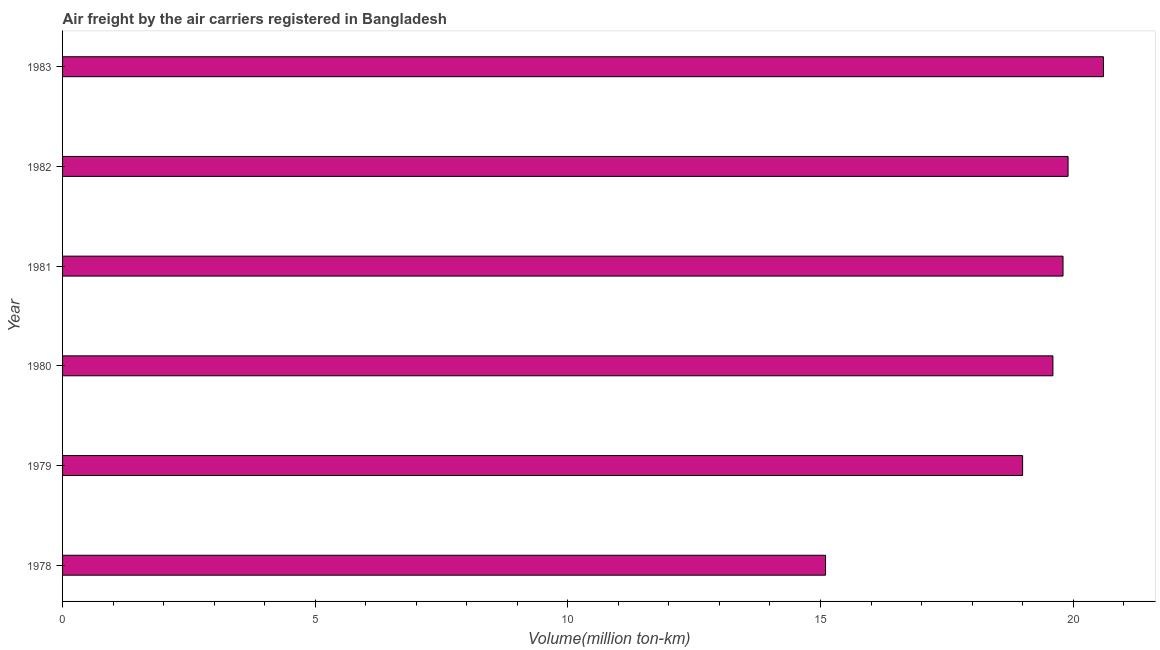Does the graph contain any zero values?
Give a very brief answer. No. Does the graph contain grids?
Ensure brevity in your answer.  No. What is the title of the graph?
Your answer should be very brief. Air freight by the air carriers registered in Bangladesh. What is the label or title of the X-axis?
Your response must be concise. Volume(million ton-km). What is the label or title of the Y-axis?
Offer a terse response. Year. Across all years, what is the maximum air freight?
Offer a very short reply. 20.6. Across all years, what is the minimum air freight?
Provide a succinct answer. 15.1. In which year was the air freight maximum?
Offer a terse response. 1983. In which year was the air freight minimum?
Make the answer very short. 1978. What is the sum of the air freight?
Make the answer very short. 114. What is the median air freight?
Your answer should be compact. 19.7. In how many years, is the air freight greater than 12 million ton-km?
Offer a terse response. 6. Do a majority of the years between 1979 and 1981 (inclusive) have air freight greater than 12 million ton-km?
Make the answer very short. Yes. What is the ratio of the air freight in 1979 to that in 1982?
Offer a terse response. 0.95. Is the difference between the air freight in 1979 and 1980 greater than the difference between any two years?
Your response must be concise. No. Is the sum of the air freight in 1980 and 1983 greater than the maximum air freight across all years?
Your response must be concise. Yes. How many bars are there?
Your answer should be compact. 6. What is the difference between two consecutive major ticks on the X-axis?
Your answer should be very brief. 5. Are the values on the major ticks of X-axis written in scientific E-notation?
Provide a succinct answer. No. What is the Volume(million ton-km) of 1978?
Your answer should be very brief. 15.1. What is the Volume(million ton-km) of 1980?
Offer a very short reply. 19.6. What is the Volume(million ton-km) in 1981?
Give a very brief answer. 19.8. What is the Volume(million ton-km) of 1982?
Make the answer very short. 19.9. What is the Volume(million ton-km) of 1983?
Keep it short and to the point. 20.6. What is the difference between the Volume(million ton-km) in 1978 and 1980?
Provide a succinct answer. -4.5. What is the difference between the Volume(million ton-km) in 1978 and 1981?
Your answer should be compact. -4.7. What is the difference between the Volume(million ton-km) in 1979 and 1980?
Give a very brief answer. -0.6. What is the difference between the Volume(million ton-km) in 1979 and 1981?
Provide a short and direct response. -0.8. What is the difference between the Volume(million ton-km) in 1979 and 1982?
Offer a terse response. -0.9. What is the difference between the Volume(million ton-km) in 1979 and 1983?
Provide a short and direct response. -1.6. What is the difference between the Volume(million ton-km) in 1980 and 1981?
Offer a terse response. -0.2. What is the difference between the Volume(million ton-km) in 1980 and 1982?
Ensure brevity in your answer.  -0.3. What is the difference between the Volume(million ton-km) in 1982 and 1983?
Provide a succinct answer. -0.7. What is the ratio of the Volume(million ton-km) in 1978 to that in 1979?
Provide a short and direct response. 0.8. What is the ratio of the Volume(million ton-km) in 1978 to that in 1980?
Offer a terse response. 0.77. What is the ratio of the Volume(million ton-km) in 1978 to that in 1981?
Provide a short and direct response. 0.76. What is the ratio of the Volume(million ton-km) in 1978 to that in 1982?
Provide a short and direct response. 0.76. What is the ratio of the Volume(million ton-km) in 1978 to that in 1983?
Provide a short and direct response. 0.73. What is the ratio of the Volume(million ton-km) in 1979 to that in 1980?
Provide a succinct answer. 0.97. What is the ratio of the Volume(million ton-km) in 1979 to that in 1981?
Provide a short and direct response. 0.96. What is the ratio of the Volume(million ton-km) in 1979 to that in 1982?
Make the answer very short. 0.95. What is the ratio of the Volume(million ton-km) in 1979 to that in 1983?
Offer a terse response. 0.92. What is the ratio of the Volume(million ton-km) in 1980 to that in 1981?
Offer a very short reply. 0.99. What is the ratio of the Volume(million ton-km) in 1980 to that in 1983?
Ensure brevity in your answer.  0.95. What is the ratio of the Volume(million ton-km) in 1982 to that in 1983?
Offer a very short reply. 0.97. 